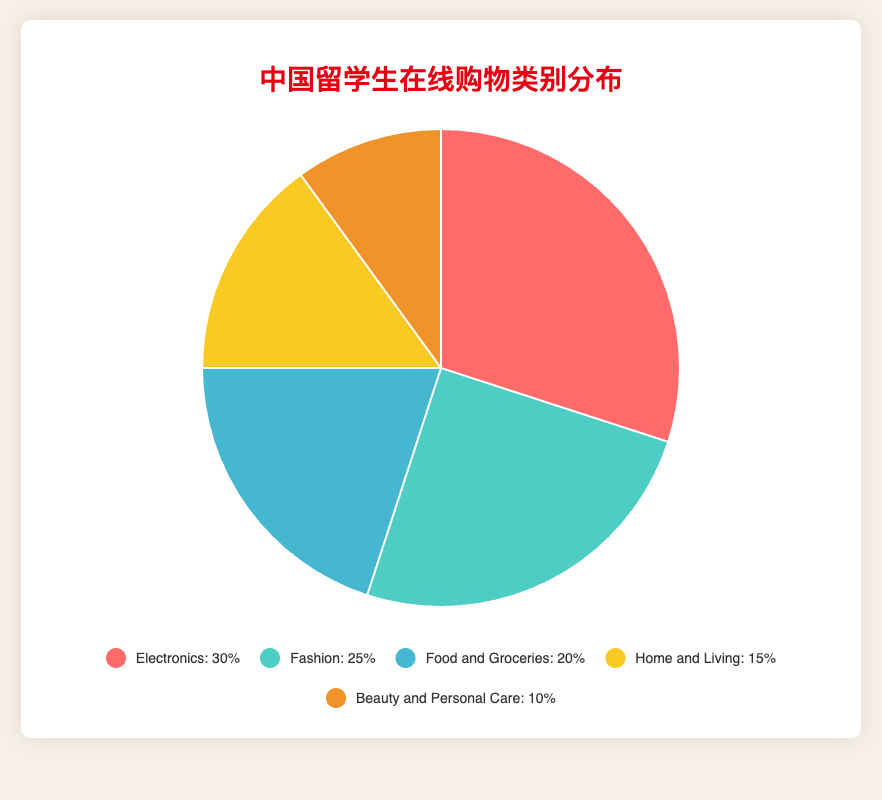What percentage of products bought by Chinese international students are related to home decor and kitchenware? In the pie chart, "Home and Living" corresponds to the home decor and kitchenware products. According to the data, the percentage for this category is 15%.
Answer: 15% Which category has the second highest percentage of purchases? From the pie chart, we can see the proportions of each category. The category with the second highest percentage after "Electronics" (30%) is "Fashion" with 25%.
Answer: Fashion What is the combined percentage of products bought in the categories "Fashion" and "Beauty and Personal Care"? To find the combined percentage, add the values for "Fashion" (25%) and "Beauty and Personal Care" (10%). Therefore, the total is 25 + 10 = 35%.
Answer: 35% How much higher is the percentage of Electronics compared to Beauty and Personal Care? The percentage for Electronics is 30%, and for Beauty and Personal Care, it is 10%. The difference is 30 - 10 = 20%.
Answer: 20% What percentage of products bought fall into categories other than "Electronics" and "Fashion"? The percentages for "Electronics" and "Fashion" are 30% and 25%, respectively. Together, this is 30 + 25 = 55%. Subtracting from 100%: 100 - 55 = 45%.
Answer: 45% What category is represented by the yellow segment in the pie chart? The yellow segment in the pie chart corresponds to "Home and Living" which has a percentage of 15%.
Answer: Home and Living Which category has the least percentage of purchases? In the pie chart, "Beauty and Personal Care" is the category with the smallest percentage, which is 10%.
Answer: Beauty and Personal Care Is the percentage of "Food and Groceries" higher or lower than the percentage of "Home and Living"? The percentage for "Food and Groceries" is 20%, and for "Home and Living" it is 15%. Therefore, "Food and Groceries" is higher than "Home and Living".
Answer: Higher How much higher is the proportion of Fashion-related purchases compared to Home and Living? The percentage for Fashion is 25%, and for Home and Living, it is 15%. The difference is 25 - 15 = 10%.
Answer: 10% 